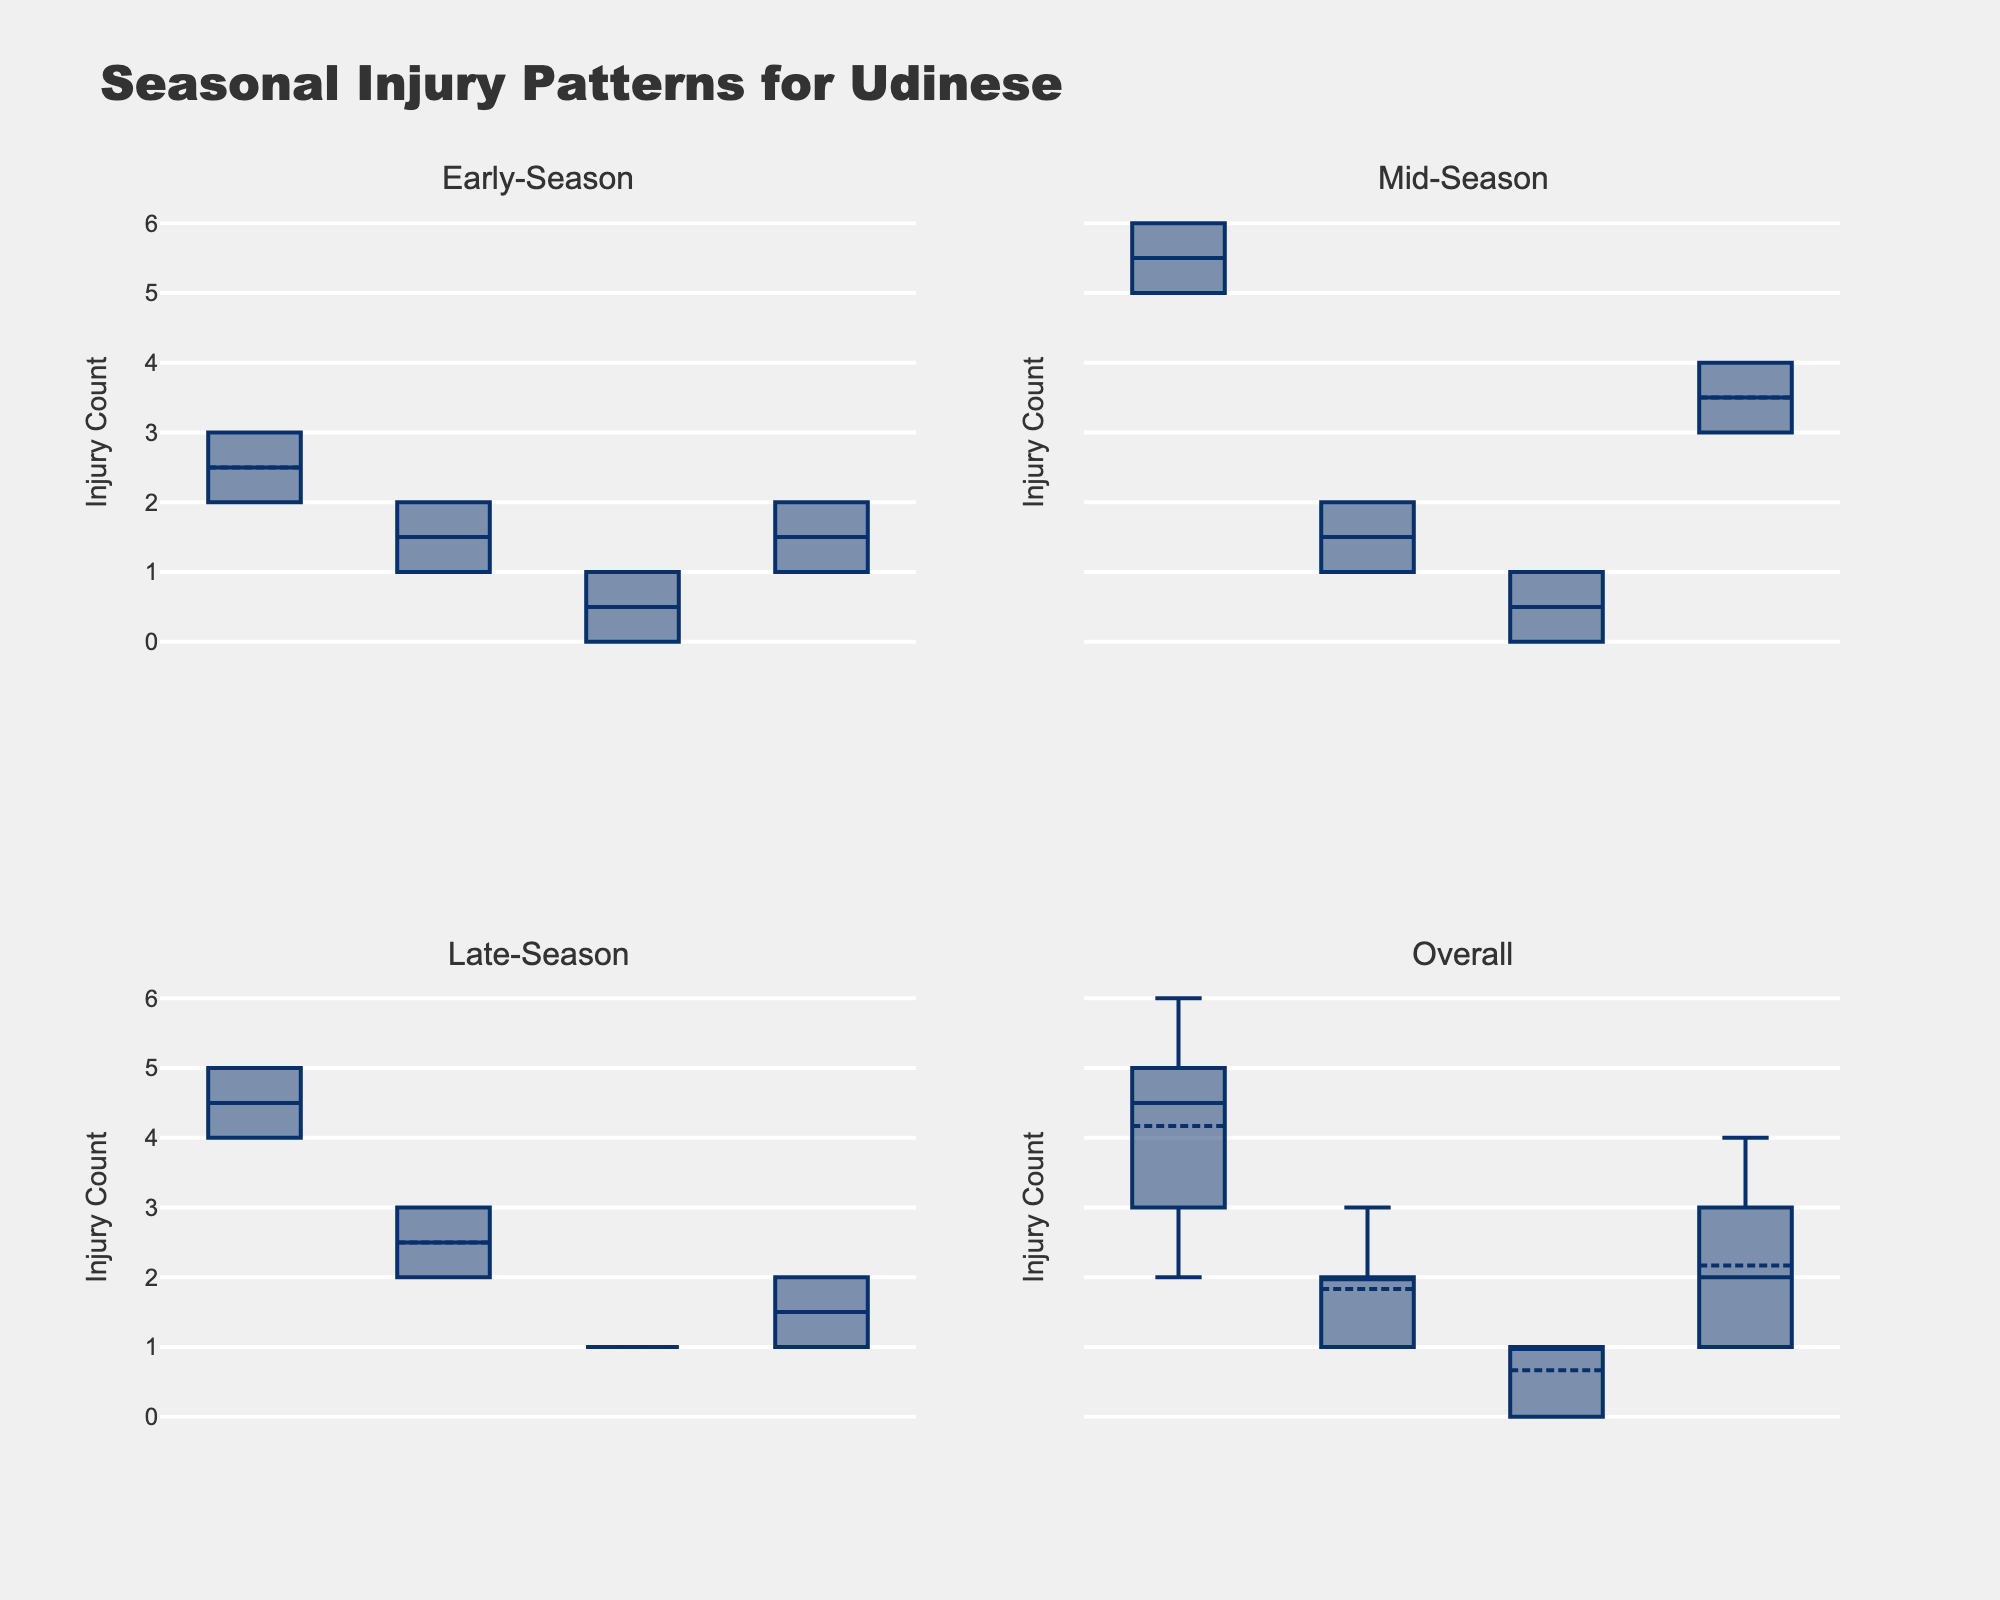What is the median count of muscular injuries during the early season? First, locate the box plot for muscular injuries in the early-season subplot. The median is indicated by the central line within the box.
Answer: 2.5 Which type of injury shows the highest median count in the mid-season? Examine the mid-season subplot and identify the box plot with the highest central line.
Answer: Muscular What is the range of ligament injuries during the late-season? The range is calculated by subtracting the minimum value from the maximum value. For the ligament injuries in the late-season subplot, determine the positions of the whiskers and calculate their difference: 3 - 2.
Answer: 1 Compare the average counts of contusion injuries between early-season and late-season. Which is higher? Calculate the mean for both seasons by averaging the values shown by box means. For early-season: (2 + 1)/2 = 1.5. For late-season: (1 + 2)/2 = 1.5. Since they are equal, there is no difference.
Answer: Equal Which season has the most variation in muscular injury counts? Variation can be identified by the length of the box and whiskers. Measure the spread for muscular injuries across all subplots to determine the season with the largest range.
Answer: Mid-season How does the median count of fractures compare across all seasons? Inspect each box plot representing fractures in the different subplots and compare the median lines. The early-season has a median of 0.5, mid-season has a median of 0, and late-season has a median of 1.
Answer: Late-season (highest) What is the combined total of ligament injuries for mid-season and late-season? Sum the counts from the mid-season (2+1) and late-season (3+2), giving (2+1+3+2).
Answer: 8 Which injury type shows the least consistency in their counts during different times of the season? Least consistency is indicated by varying median lines and larger spreads in the box plots. Identify the injury type with the highest variability across subplots.
Answer: Contusion Looking at the overall subplot, which injury type has the most skewed distribution? Skewed distribution can be identified by the position of the median within the box and the length of the whiskers. The muscular injuries' box plot shows the maximum skew.
Answer: Muscular 